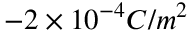Convert formula to latex. <formula><loc_0><loc_0><loc_500><loc_500>- 2 \times 1 0 ^ { - 4 } C / m ^ { 2 }</formula> 